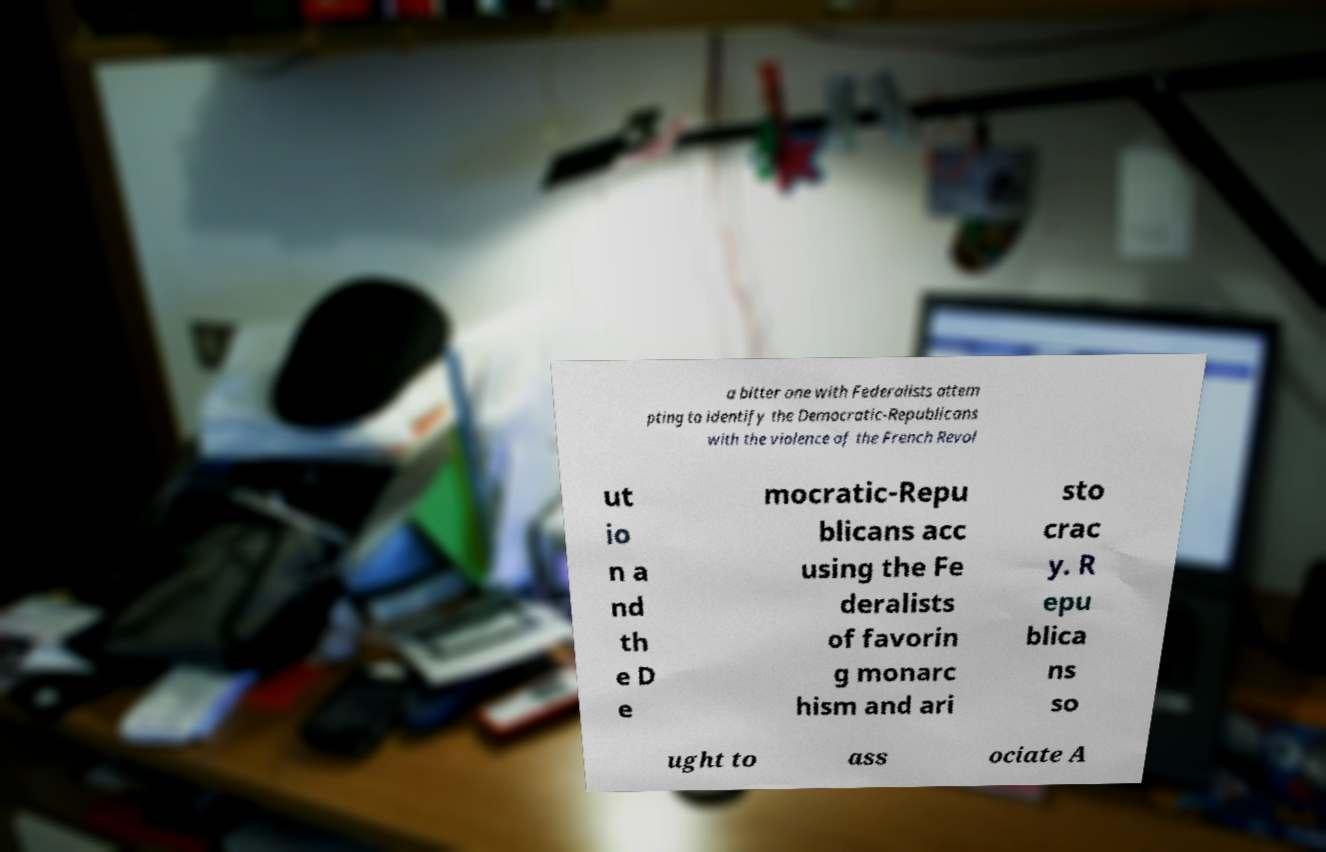I need the written content from this picture converted into text. Can you do that? a bitter one with Federalists attem pting to identify the Democratic-Republicans with the violence of the French Revol ut io n a nd th e D e mocratic-Repu blicans acc using the Fe deralists of favorin g monarc hism and ari sto crac y. R epu blica ns so ught to ass ociate A 